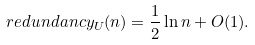<formula> <loc_0><loc_0><loc_500><loc_500>\ r e d u n d a n c y _ { U } ( n ) = \frac { 1 } { 2 } \ln n + O ( 1 ) .</formula> 